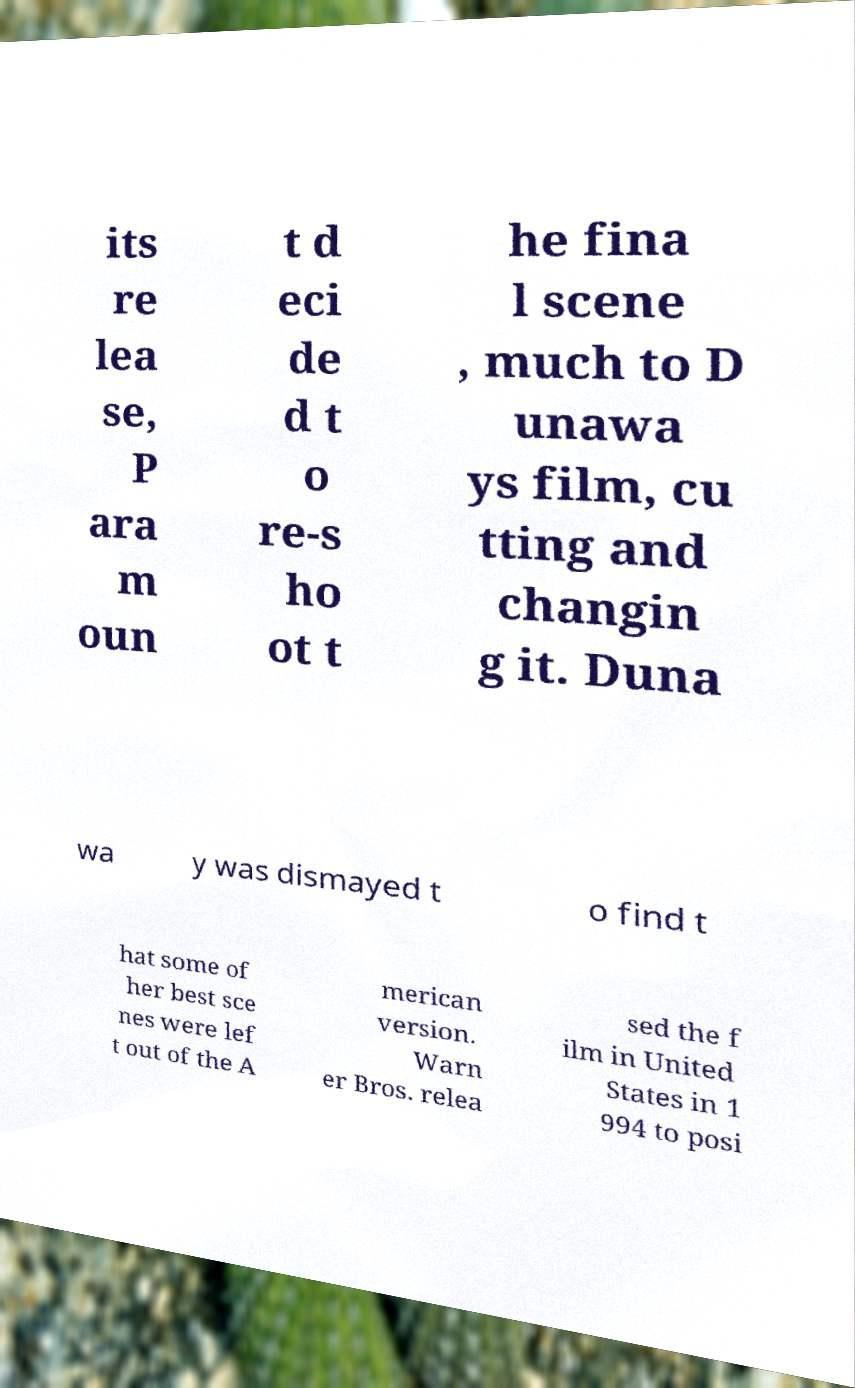For documentation purposes, I need the text within this image transcribed. Could you provide that? its re lea se, P ara m oun t d eci de d t o re-s ho ot t he fina l scene , much to D unawa ys film, cu tting and changin g it. Duna wa y was dismayed t o find t hat some of her best sce nes were lef t out of the A merican version. Warn er Bros. relea sed the f ilm in United States in 1 994 to posi 